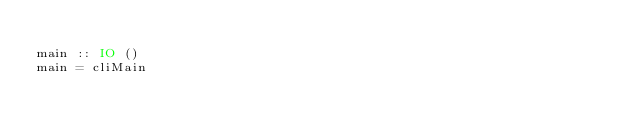Convert code to text. <code><loc_0><loc_0><loc_500><loc_500><_Haskell_>
main :: IO ()
main = cliMain
</code> 